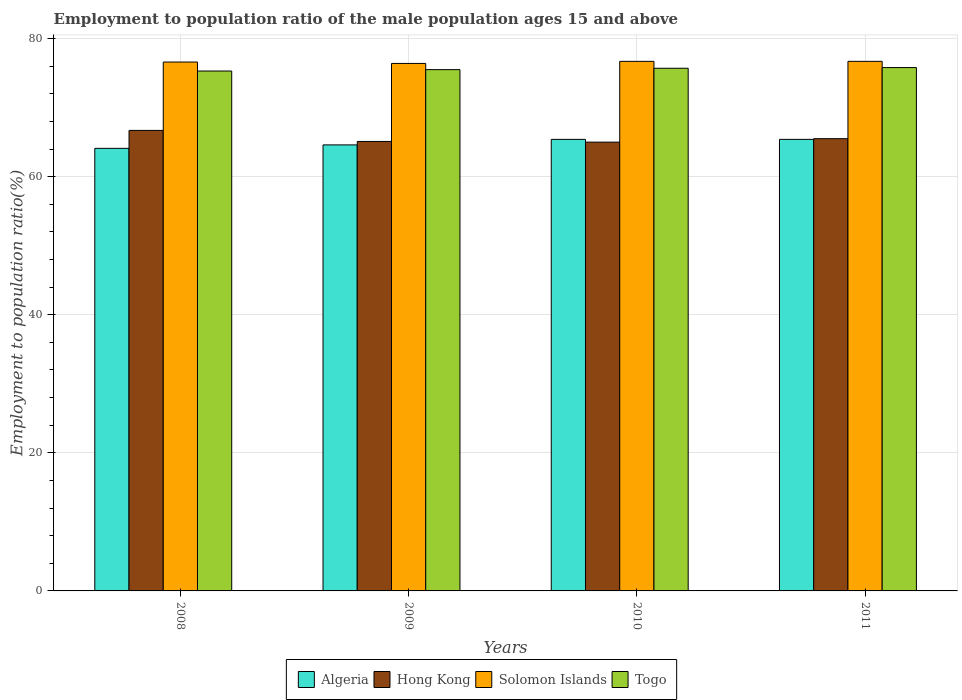How many groups of bars are there?
Offer a very short reply. 4. Are the number of bars per tick equal to the number of legend labels?
Ensure brevity in your answer.  Yes. How many bars are there on the 4th tick from the left?
Your answer should be compact. 4. What is the employment to population ratio in Algeria in 2011?
Your response must be concise. 65.4. Across all years, what is the maximum employment to population ratio in Togo?
Keep it short and to the point. 75.8. Across all years, what is the minimum employment to population ratio in Algeria?
Ensure brevity in your answer.  64.1. What is the total employment to population ratio in Togo in the graph?
Your response must be concise. 302.3. What is the difference between the employment to population ratio in Togo in 2009 and that in 2010?
Your response must be concise. -0.2. What is the difference between the employment to population ratio in Togo in 2011 and the employment to population ratio in Hong Kong in 2010?
Keep it short and to the point. 10.8. What is the average employment to population ratio in Algeria per year?
Your answer should be compact. 64.87. In the year 2009, what is the difference between the employment to population ratio in Algeria and employment to population ratio in Togo?
Offer a terse response. -10.9. In how many years, is the employment to population ratio in Algeria greater than 52 %?
Provide a succinct answer. 4. What is the ratio of the employment to population ratio in Togo in 2008 to that in 2010?
Offer a very short reply. 0.99. What is the difference between the highest and the second highest employment to population ratio in Togo?
Keep it short and to the point. 0.1. What is the difference between the highest and the lowest employment to population ratio in Algeria?
Offer a very short reply. 1.3. In how many years, is the employment to population ratio in Algeria greater than the average employment to population ratio in Algeria taken over all years?
Your response must be concise. 2. Is the sum of the employment to population ratio in Solomon Islands in 2010 and 2011 greater than the maximum employment to population ratio in Hong Kong across all years?
Your response must be concise. Yes. What does the 4th bar from the left in 2011 represents?
Offer a terse response. Togo. What does the 3rd bar from the right in 2011 represents?
Give a very brief answer. Hong Kong. Are all the bars in the graph horizontal?
Make the answer very short. No. How many years are there in the graph?
Provide a succinct answer. 4. Are the values on the major ticks of Y-axis written in scientific E-notation?
Your response must be concise. No. Does the graph contain any zero values?
Offer a terse response. No. Does the graph contain grids?
Make the answer very short. Yes. Where does the legend appear in the graph?
Your response must be concise. Bottom center. How many legend labels are there?
Keep it short and to the point. 4. What is the title of the graph?
Your answer should be compact. Employment to population ratio of the male population ages 15 and above. Does "Mauritius" appear as one of the legend labels in the graph?
Your response must be concise. No. What is the label or title of the X-axis?
Your answer should be compact. Years. What is the label or title of the Y-axis?
Give a very brief answer. Employment to population ratio(%). What is the Employment to population ratio(%) in Algeria in 2008?
Your answer should be very brief. 64.1. What is the Employment to population ratio(%) of Hong Kong in 2008?
Offer a terse response. 66.7. What is the Employment to population ratio(%) in Solomon Islands in 2008?
Offer a very short reply. 76.6. What is the Employment to population ratio(%) of Togo in 2008?
Your response must be concise. 75.3. What is the Employment to population ratio(%) in Algeria in 2009?
Offer a very short reply. 64.6. What is the Employment to population ratio(%) of Hong Kong in 2009?
Make the answer very short. 65.1. What is the Employment to population ratio(%) of Solomon Islands in 2009?
Keep it short and to the point. 76.4. What is the Employment to population ratio(%) of Togo in 2009?
Make the answer very short. 75.5. What is the Employment to population ratio(%) of Algeria in 2010?
Your response must be concise. 65.4. What is the Employment to population ratio(%) of Hong Kong in 2010?
Your response must be concise. 65. What is the Employment to population ratio(%) in Solomon Islands in 2010?
Your answer should be compact. 76.7. What is the Employment to population ratio(%) of Togo in 2010?
Make the answer very short. 75.7. What is the Employment to population ratio(%) of Algeria in 2011?
Your answer should be compact. 65.4. What is the Employment to population ratio(%) of Hong Kong in 2011?
Provide a short and direct response. 65.5. What is the Employment to population ratio(%) of Solomon Islands in 2011?
Offer a terse response. 76.7. What is the Employment to population ratio(%) in Togo in 2011?
Provide a succinct answer. 75.8. Across all years, what is the maximum Employment to population ratio(%) in Algeria?
Provide a succinct answer. 65.4. Across all years, what is the maximum Employment to population ratio(%) of Hong Kong?
Provide a short and direct response. 66.7. Across all years, what is the maximum Employment to population ratio(%) of Solomon Islands?
Provide a succinct answer. 76.7. Across all years, what is the maximum Employment to population ratio(%) in Togo?
Ensure brevity in your answer.  75.8. Across all years, what is the minimum Employment to population ratio(%) of Algeria?
Ensure brevity in your answer.  64.1. Across all years, what is the minimum Employment to population ratio(%) in Hong Kong?
Give a very brief answer. 65. Across all years, what is the minimum Employment to population ratio(%) of Solomon Islands?
Your response must be concise. 76.4. Across all years, what is the minimum Employment to population ratio(%) of Togo?
Offer a terse response. 75.3. What is the total Employment to population ratio(%) of Algeria in the graph?
Your answer should be compact. 259.5. What is the total Employment to population ratio(%) of Hong Kong in the graph?
Offer a very short reply. 262.3. What is the total Employment to population ratio(%) in Solomon Islands in the graph?
Your answer should be compact. 306.4. What is the total Employment to population ratio(%) of Togo in the graph?
Offer a very short reply. 302.3. What is the difference between the Employment to population ratio(%) of Hong Kong in 2008 and that in 2009?
Make the answer very short. 1.6. What is the difference between the Employment to population ratio(%) of Solomon Islands in 2008 and that in 2009?
Your answer should be compact. 0.2. What is the difference between the Employment to population ratio(%) in Hong Kong in 2008 and that in 2010?
Ensure brevity in your answer.  1.7. What is the difference between the Employment to population ratio(%) in Solomon Islands in 2008 and that in 2010?
Keep it short and to the point. -0.1. What is the difference between the Employment to population ratio(%) of Algeria in 2008 and that in 2011?
Offer a very short reply. -1.3. What is the difference between the Employment to population ratio(%) of Solomon Islands in 2008 and that in 2011?
Your response must be concise. -0.1. What is the difference between the Employment to population ratio(%) of Togo in 2008 and that in 2011?
Provide a short and direct response. -0.5. What is the difference between the Employment to population ratio(%) of Algeria in 2009 and that in 2011?
Make the answer very short. -0.8. What is the difference between the Employment to population ratio(%) of Hong Kong in 2009 and that in 2011?
Keep it short and to the point. -0.4. What is the difference between the Employment to population ratio(%) in Algeria in 2010 and that in 2011?
Your answer should be very brief. 0. What is the difference between the Employment to population ratio(%) in Algeria in 2008 and the Employment to population ratio(%) in Hong Kong in 2009?
Offer a very short reply. -1. What is the difference between the Employment to population ratio(%) in Algeria in 2008 and the Employment to population ratio(%) in Togo in 2009?
Keep it short and to the point. -11.4. What is the difference between the Employment to population ratio(%) of Algeria in 2008 and the Employment to population ratio(%) of Solomon Islands in 2010?
Your answer should be compact. -12.6. What is the difference between the Employment to population ratio(%) in Algeria in 2008 and the Employment to population ratio(%) in Togo in 2010?
Your answer should be compact. -11.6. What is the difference between the Employment to population ratio(%) in Solomon Islands in 2008 and the Employment to population ratio(%) in Togo in 2010?
Provide a succinct answer. 0.9. What is the difference between the Employment to population ratio(%) in Algeria in 2008 and the Employment to population ratio(%) in Hong Kong in 2011?
Keep it short and to the point. -1.4. What is the difference between the Employment to population ratio(%) of Algeria in 2008 and the Employment to population ratio(%) of Solomon Islands in 2011?
Offer a very short reply. -12.6. What is the difference between the Employment to population ratio(%) of Algeria in 2008 and the Employment to population ratio(%) of Togo in 2011?
Ensure brevity in your answer.  -11.7. What is the difference between the Employment to population ratio(%) of Algeria in 2009 and the Employment to population ratio(%) of Hong Kong in 2010?
Make the answer very short. -0.4. What is the difference between the Employment to population ratio(%) of Algeria in 2009 and the Employment to population ratio(%) of Solomon Islands in 2010?
Provide a short and direct response. -12.1. What is the difference between the Employment to population ratio(%) of Algeria in 2009 and the Employment to population ratio(%) of Togo in 2010?
Ensure brevity in your answer.  -11.1. What is the difference between the Employment to population ratio(%) in Hong Kong in 2009 and the Employment to population ratio(%) in Togo in 2010?
Make the answer very short. -10.6. What is the difference between the Employment to population ratio(%) in Algeria in 2009 and the Employment to population ratio(%) in Hong Kong in 2011?
Keep it short and to the point. -0.9. What is the difference between the Employment to population ratio(%) in Algeria in 2009 and the Employment to population ratio(%) in Togo in 2011?
Provide a succinct answer. -11.2. What is the difference between the Employment to population ratio(%) of Solomon Islands in 2009 and the Employment to population ratio(%) of Togo in 2011?
Offer a very short reply. 0.6. What is the difference between the Employment to population ratio(%) in Algeria in 2010 and the Employment to population ratio(%) in Solomon Islands in 2011?
Offer a terse response. -11.3. What is the difference between the Employment to population ratio(%) of Hong Kong in 2010 and the Employment to population ratio(%) of Solomon Islands in 2011?
Your answer should be compact. -11.7. What is the difference between the Employment to population ratio(%) of Hong Kong in 2010 and the Employment to population ratio(%) of Togo in 2011?
Offer a very short reply. -10.8. What is the difference between the Employment to population ratio(%) of Solomon Islands in 2010 and the Employment to population ratio(%) of Togo in 2011?
Offer a terse response. 0.9. What is the average Employment to population ratio(%) in Algeria per year?
Your response must be concise. 64.88. What is the average Employment to population ratio(%) in Hong Kong per year?
Your response must be concise. 65.58. What is the average Employment to population ratio(%) of Solomon Islands per year?
Ensure brevity in your answer.  76.6. What is the average Employment to population ratio(%) of Togo per year?
Make the answer very short. 75.58. In the year 2008, what is the difference between the Employment to population ratio(%) of Algeria and Employment to population ratio(%) of Hong Kong?
Make the answer very short. -2.6. In the year 2008, what is the difference between the Employment to population ratio(%) in Algeria and Employment to population ratio(%) in Solomon Islands?
Your answer should be very brief. -12.5. In the year 2008, what is the difference between the Employment to population ratio(%) of Algeria and Employment to population ratio(%) of Togo?
Your answer should be very brief. -11.2. In the year 2008, what is the difference between the Employment to population ratio(%) in Hong Kong and Employment to population ratio(%) in Togo?
Your answer should be very brief. -8.6. In the year 2009, what is the difference between the Employment to population ratio(%) in Algeria and Employment to population ratio(%) in Solomon Islands?
Offer a very short reply. -11.8. In the year 2009, what is the difference between the Employment to population ratio(%) of Algeria and Employment to population ratio(%) of Togo?
Offer a terse response. -10.9. In the year 2009, what is the difference between the Employment to population ratio(%) in Hong Kong and Employment to population ratio(%) in Solomon Islands?
Offer a very short reply. -11.3. In the year 2009, what is the difference between the Employment to population ratio(%) of Hong Kong and Employment to population ratio(%) of Togo?
Make the answer very short. -10.4. In the year 2010, what is the difference between the Employment to population ratio(%) in Hong Kong and Employment to population ratio(%) in Solomon Islands?
Give a very brief answer. -11.7. In the year 2010, what is the difference between the Employment to population ratio(%) in Solomon Islands and Employment to population ratio(%) in Togo?
Your answer should be very brief. 1. In the year 2011, what is the difference between the Employment to population ratio(%) of Algeria and Employment to population ratio(%) of Hong Kong?
Make the answer very short. -0.1. In the year 2011, what is the difference between the Employment to population ratio(%) in Algeria and Employment to population ratio(%) in Togo?
Your answer should be very brief. -10.4. In the year 2011, what is the difference between the Employment to population ratio(%) of Hong Kong and Employment to population ratio(%) of Togo?
Make the answer very short. -10.3. In the year 2011, what is the difference between the Employment to population ratio(%) of Solomon Islands and Employment to population ratio(%) of Togo?
Your response must be concise. 0.9. What is the ratio of the Employment to population ratio(%) in Algeria in 2008 to that in 2009?
Give a very brief answer. 0.99. What is the ratio of the Employment to population ratio(%) of Hong Kong in 2008 to that in 2009?
Give a very brief answer. 1.02. What is the ratio of the Employment to population ratio(%) of Solomon Islands in 2008 to that in 2009?
Your answer should be very brief. 1. What is the ratio of the Employment to population ratio(%) in Togo in 2008 to that in 2009?
Offer a very short reply. 1. What is the ratio of the Employment to population ratio(%) in Algeria in 2008 to that in 2010?
Keep it short and to the point. 0.98. What is the ratio of the Employment to population ratio(%) in Hong Kong in 2008 to that in 2010?
Your answer should be compact. 1.03. What is the ratio of the Employment to population ratio(%) of Togo in 2008 to that in 2010?
Your answer should be compact. 0.99. What is the ratio of the Employment to population ratio(%) of Algeria in 2008 to that in 2011?
Offer a very short reply. 0.98. What is the ratio of the Employment to population ratio(%) in Hong Kong in 2008 to that in 2011?
Give a very brief answer. 1.02. What is the ratio of the Employment to population ratio(%) in Solomon Islands in 2008 to that in 2011?
Offer a terse response. 1. What is the ratio of the Employment to population ratio(%) of Togo in 2008 to that in 2011?
Provide a succinct answer. 0.99. What is the ratio of the Employment to population ratio(%) in Algeria in 2009 to that in 2010?
Your response must be concise. 0.99. What is the ratio of the Employment to population ratio(%) of Hong Kong in 2009 to that in 2010?
Provide a short and direct response. 1. What is the ratio of the Employment to population ratio(%) in Solomon Islands in 2009 to that in 2010?
Make the answer very short. 1. What is the ratio of the Employment to population ratio(%) of Togo in 2009 to that in 2010?
Your response must be concise. 1. What is the ratio of the Employment to population ratio(%) in Algeria in 2009 to that in 2011?
Offer a terse response. 0.99. What is the ratio of the Employment to population ratio(%) in Hong Kong in 2009 to that in 2011?
Make the answer very short. 0.99. What is the ratio of the Employment to population ratio(%) in Togo in 2009 to that in 2011?
Provide a succinct answer. 1. What is the ratio of the Employment to population ratio(%) in Algeria in 2010 to that in 2011?
Your answer should be very brief. 1. What is the difference between the highest and the second highest Employment to population ratio(%) in Hong Kong?
Offer a very short reply. 1.2. What is the difference between the highest and the lowest Employment to population ratio(%) in Hong Kong?
Offer a very short reply. 1.7. What is the difference between the highest and the lowest Employment to population ratio(%) in Solomon Islands?
Make the answer very short. 0.3. What is the difference between the highest and the lowest Employment to population ratio(%) in Togo?
Provide a short and direct response. 0.5. 